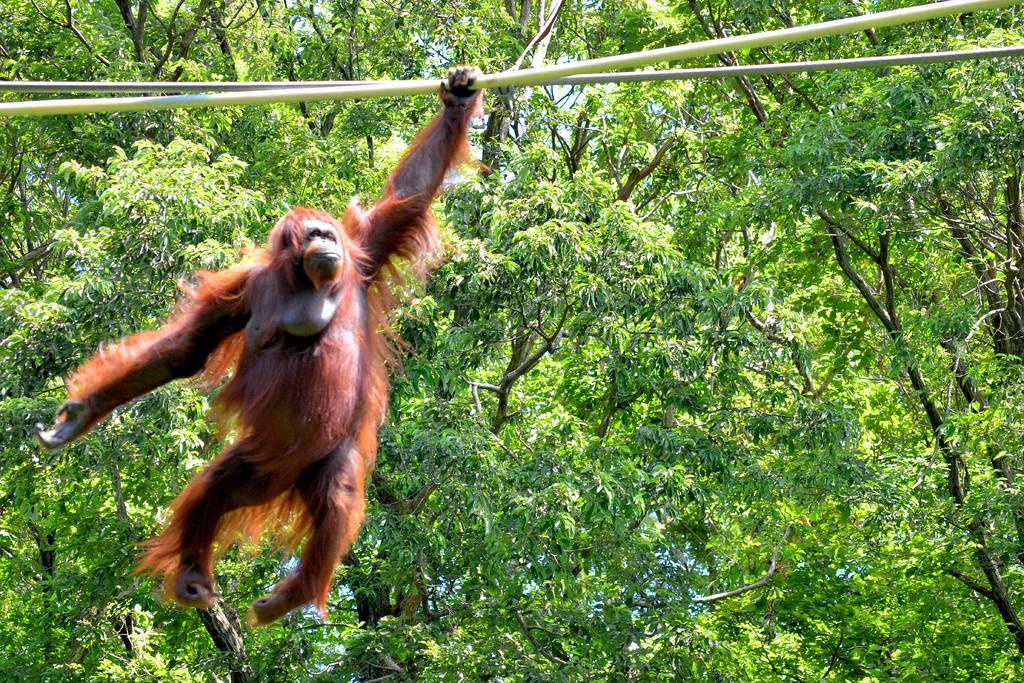What animal is present in the image? There is a monkey in the image. What is the monkey holding in the image? The monkey is holding a white color pole. What color is the monkey in the image? The monkey is in brown color. What type of natural environment can be seen in the image? There are trees visible in the image. What type of star is visible in the image? There is no star visible in the image; it features a monkey holding a white color pole and trees in the background. Who gave their approval for the monkey to hold the pole in the image? There is no indication in the image that anyone gave approval for the monkey to hold the pole, as it is a still image and not a live event. 